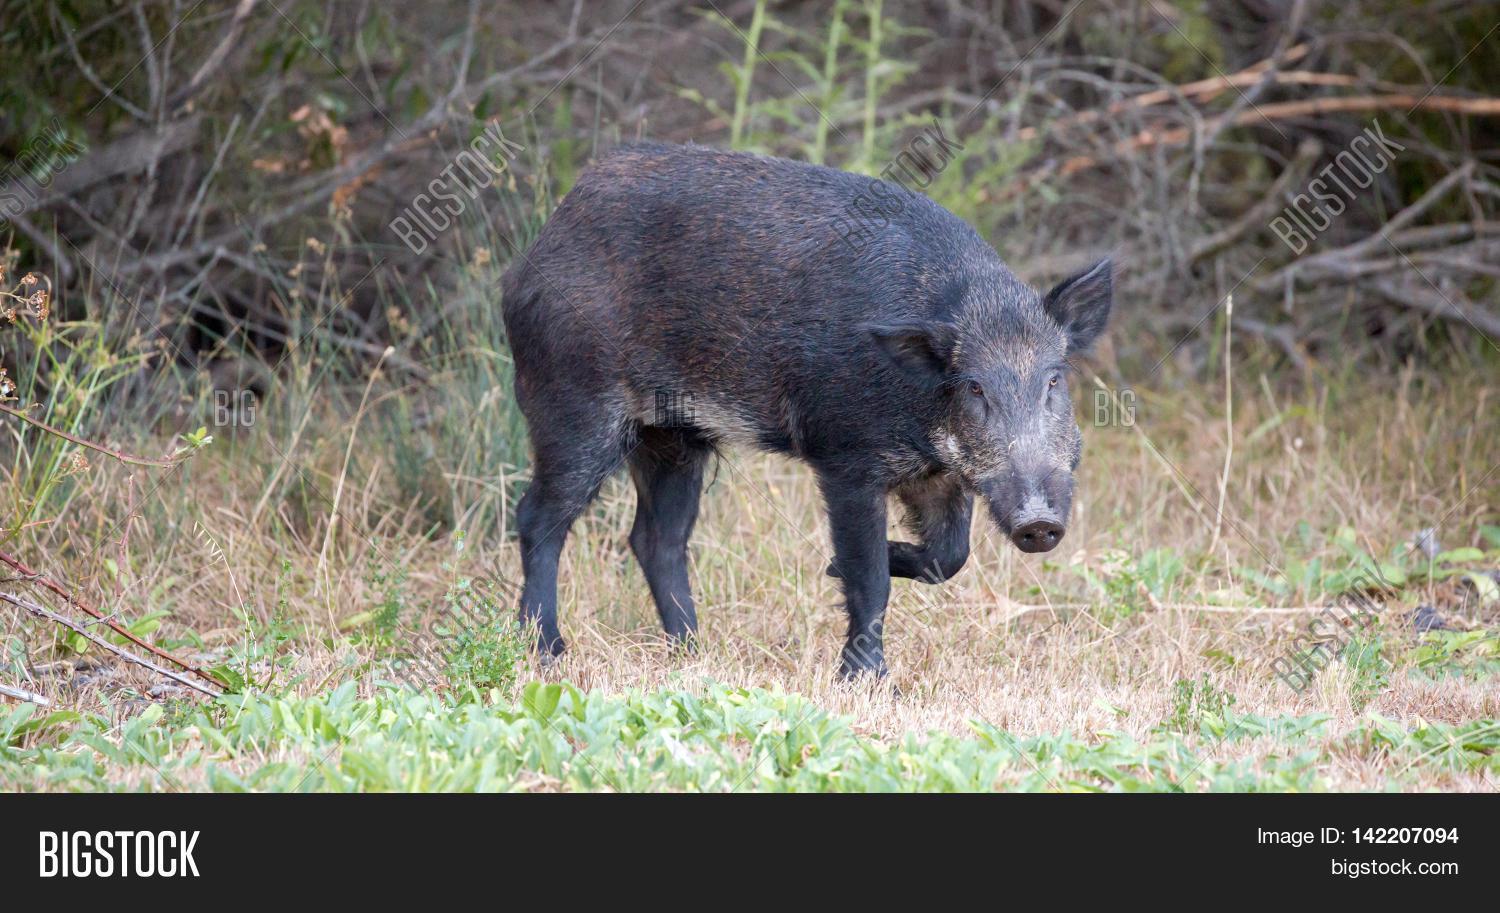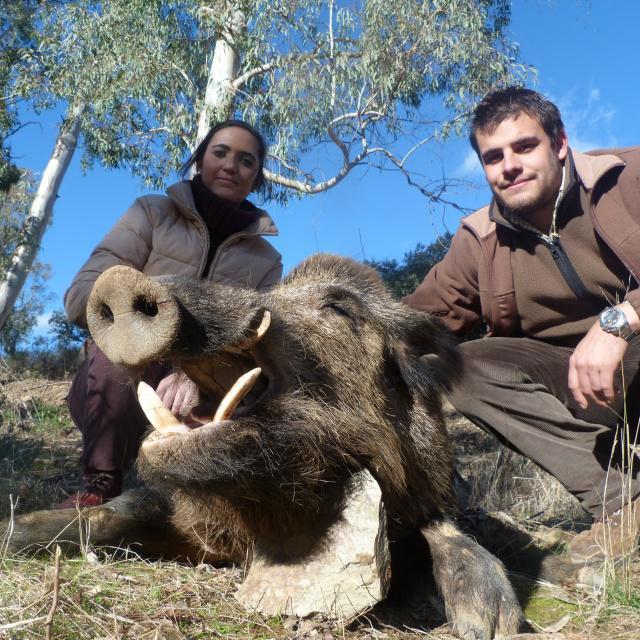The first image is the image on the left, the second image is the image on the right. For the images shown, is this caption "Exactly two living beings are in a forest." true? Answer yes or no. No. The first image is the image on the left, the second image is the image on the right. Evaluate the accuracy of this statement regarding the images: "Each image contains exactly one wild pig, which is standing up and lacks distinctive stripes.". Is it true? Answer yes or no. No. 